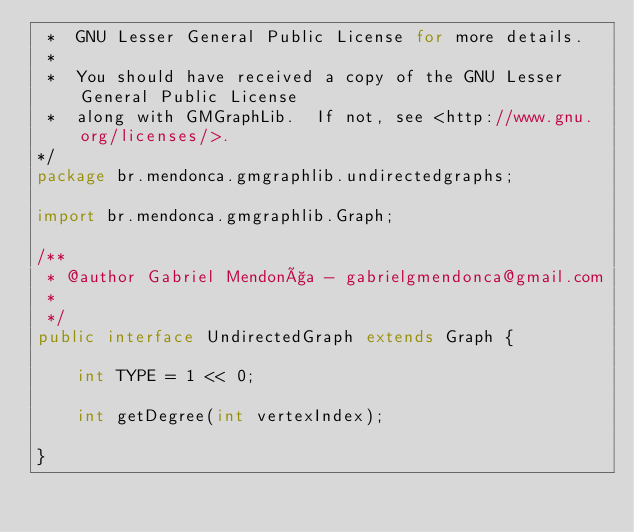Convert code to text. <code><loc_0><loc_0><loc_500><loc_500><_Java_> *  GNU Lesser General Public License for more details.
 *  
 *  You should have received a copy of the GNU Lesser General Public License
 *  along with GMGraphLib.  If not, see <http://www.gnu.org/licenses/>.
*/
package br.mendonca.gmgraphlib.undirectedgraphs;

import br.mendonca.gmgraphlib.Graph;

/**
 * @author Gabriel Mendonça - gabrielgmendonca@gmail.com
 *
 */
public interface UndirectedGraph extends Graph {

	int TYPE = 1 << 0;

	int getDegree(int vertexIndex);
	
}
</code> 